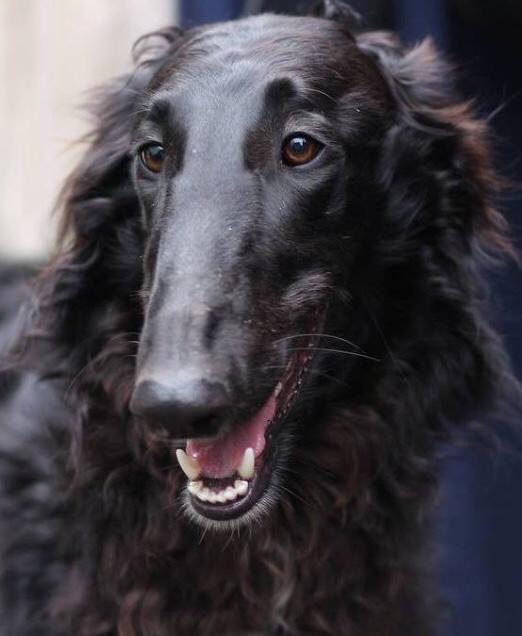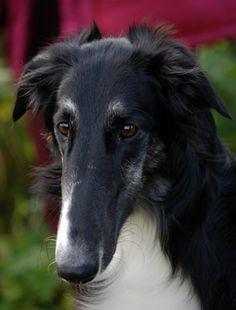The first image is the image on the left, the second image is the image on the right. Given the left and right images, does the statement "At least one dog has a dark face, and the dogs in the left and right images have the same face position, with eyes gazing the same direction." hold true? Answer yes or no. Yes. The first image is the image on the left, the second image is the image on the right. Examine the images to the left and right. Is the description "In both images only the head of the dog can be seen and not the rest of the dogs body." accurate? Answer yes or no. Yes. 